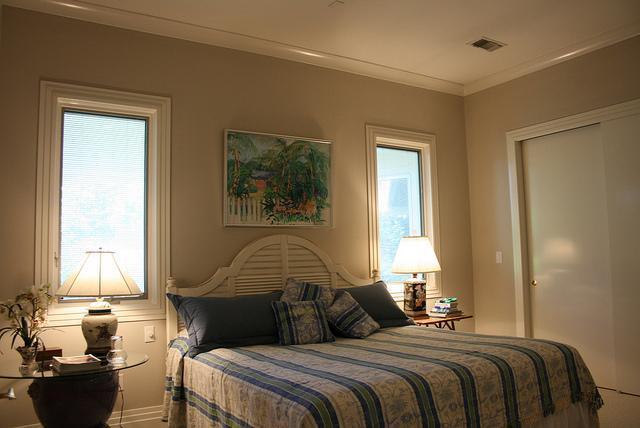How many windows are in this room?
Give a very brief answer. 2. How many decorative pillows are on the bed?
Give a very brief answer. 3. How many people are holding a baseball bat?
Give a very brief answer. 0. 